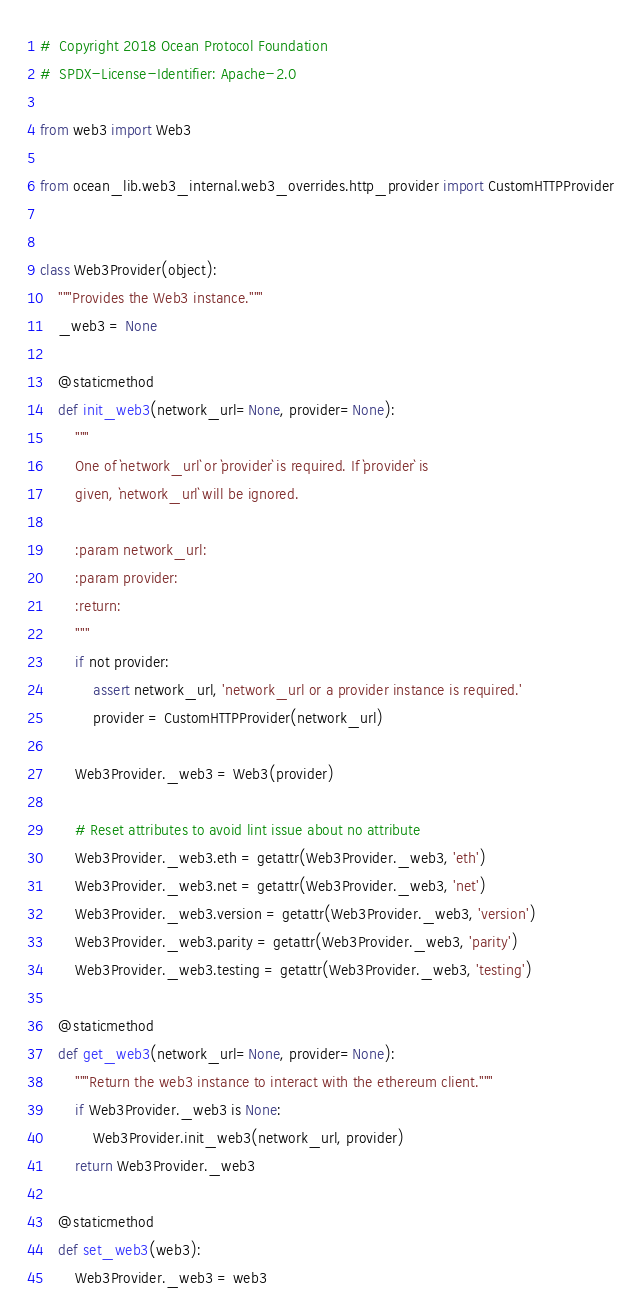Convert code to text. <code><loc_0><loc_0><loc_500><loc_500><_Python_>#  Copyright 2018 Ocean Protocol Foundation
#  SPDX-License-Identifier: Apache-2.0

from web3 import Web3

from ocean_lib.web3_internal.web3_overrides.http_provider import CustomHTTPProvider


class Web3Provider(object):
    """Provides the Web3 instance."""
    _web3 = None

    @staticmethod
    def init_web3(network_url=None, provider=None):
        """
        One of `network_url` or `provider` is required. If `provider` is
        given, `network_url` will be ignored.

        :param network_url:
        :param provider:
        :return:
        """
        if not provider:
            assert network_url, 'network_url or a provider instance is required.'
            provider = CustomHTTPProvider(network_url)

        Web3Provider._web3 = Web3(provider)

        # Reset attributes to avoid lint issue about no attribute
        Web3Provider._web3.eth = getattr(Web3Provider._web3, 'eth')
        Web3Provider._web3.net = getattr(Web3Provider._web3, 'net')
        Web3Provider._web3.version = getattr(Web3Provider._web3, 'version')
        Web3Provider._web3.parity = getattr(Web3Provider._web3, 'parity')
        Web3Provider._web3.testing = getattr(Web3Provider._web3, 'testing')

    @staticmethod
    def get_web3(network_url=None, provider=None):
        """Return the web3 instance to interact with the ethereum client."""
        if Web3Provider._web3 is None:
            Web3Provider.init_web3(network_url, provider)
        return Web3Provider._web3

    @staticmethod
    def set_web3(web3):
        Web3Provider._web3 = web3
</code> 